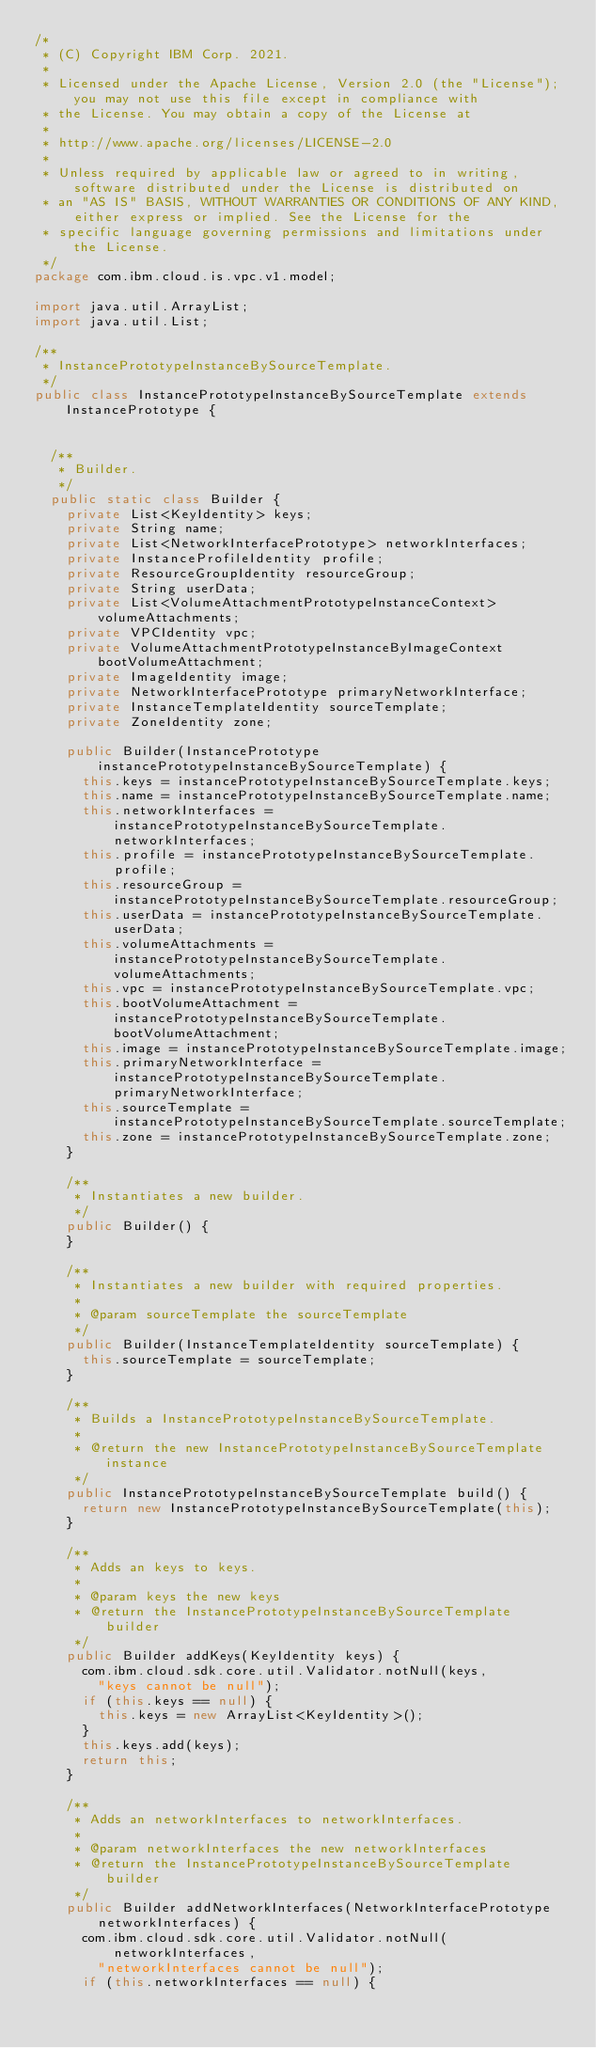Convert code to text. <code><loc_0><loc_0><loc_500><loc_500><_Java_>/*
 * (C) Copyright IBM Corp. 2021.
 *
 * Licensed under the Apache License, Version 2.0 (the "License"); you may not use this file except in compliance with
 * the License. You may obtain a copy of the License at
 *
 * http://www.apache.org/licenses/LICENSE-2.0
 *
 * Unless required by applicable law or agreed to in writing, software distributed under the License is distributed on
 * an "AS IS" BASIS, WITHOUT WARRANTIES OR CONDITIONS OF ANY KIND, either express or implied. See the License for the
 * specific language governing permissions and limitations under the License.
 */
package com.ibm.cloud.is.vpc.v1.model;

import java.util.ArrayList;
import java.util.List;

/**
 * InstancePrototypeInstanceBySourceTemplate.
 */
public class InstancePrototypeInstanceBySourceTemplate extends InstancePrototype {


  /**
   * Builder.
   */
  public static class Builder {
    private List<KeyIdentity> keys;
    private String name;
    private List<NetworkInterfacePrototype> networkInterfaces;
    private InstanceProfileIdentity profile;
    private ResourceGroupIdentity resourceGroup;
    private String userData;
    private List<VolumeAttachmentPrototypeInstanceContext> volumeAttachments;
    private VPCIdentity vpc;
    private VolumeAttachmentPrototypeInstanceByImageContext bootVolumeAttachment;
    private ImageIdentity image;
    private NetworkInterfacePrototype primaryNetworkInterface;
    private InstanceTemplateIdentity sourceTemplate;
    private ZoneIdentity zone;

    public Builder(InstancePrototype instancePrototypeInstanceBySourceTemplate) {
      this.keys = instancePrototypeInstanceBySourceTemplate.keys;
      this.name = instancePrototypeInstanceBySourceTemplate.name;
      this.networkInterfaces = instancePrototypeInstanceBySourceTemplate.networkInterfaces;
      this.profile = instancePrototypeInstanceBySourceTemplate.profile;
      this.resourceGroup = instancePrototypeInstanceBySourceTemplate.resourceGroup;
      this.userData = instancePrototypeInstanceBySourceTemplate.userData;
      this.volumeAttachments = instancePrototypeInstanceBySourceTemplate.volumeAttachments;
      this.vpc = instancePrototypeInstanceBySourceTemplate.vpc;
      this.bootVolumeAttachment = instancePrototypeInstanceBySourceTemplate.bootVolumeAttachment;
      this.image = instancePrototypeInstanceBySourceTemplate.image;
      this.primaryNetworkInterface = instancePrototypeInstanceBySourceTemplate.primaryNetworkInterface;
      this.sourceTemplate = instancePrototypeInstanceBySourceTemplate.sourceTemplate;
      this.zone = instancePrototypeInstanceBySourceTemplate.zone;
    }

    /**
     * Instantiates a new builder.
     */
    public Builder() {
    }

    /**
     * Instantiates a new builder with required properties.
     *
     * @param sourceTemplate the sourceTemplate
     */
    public Builder(InstanceTemplateIdentity sourceTemplate) {
      this.sourceTemplate = sourceTemplate;
    }

    /**
     * Builds a InstancePrototypeInstanceBySourceTemplate.
     *
     * @return the new InstancePrototypeInstanceBySourceTemplate instance
     */
    public InstancePrototypeInstanceBySourceTemplate build() {
      return new InstancePrototypeInstanceBySourceTemplate(this);
    }

    /**
     * Adds an keys to keys.
     *
     * @param keys the new keys
     * @return the InstancePrototypeInstanceBySourceTemplate builder
     */
    public Builder addKeys(KeyIdentity keys) {
      com.ibm.cloud.sdk.core.util.Validator.notNull(keys,
        "keys cannot be null");
      if (this.keys == null) {
        this.keys = new ArrayList<KeyIdentity>();
      }
      this.keys.add(keys);
      return this;
    }

    /**
     * Adds an networkInterfaces to networkInterfaces.
     *
     * @param networkInterfaces the new networkInterfaces
     * @return the InstancePrototypeInstanceBySourceTemplate builder
     */
    public Builder addNetworkInterfaces(NetworkInterfacePrototype networkInterfaces) {
      com.ibm.cloud.sdk.core.util.Validator.notNull(networkInterfaces,
        "networkInterfaces cannot be null");
      if (this.networkInterfaces == null) {</code> 